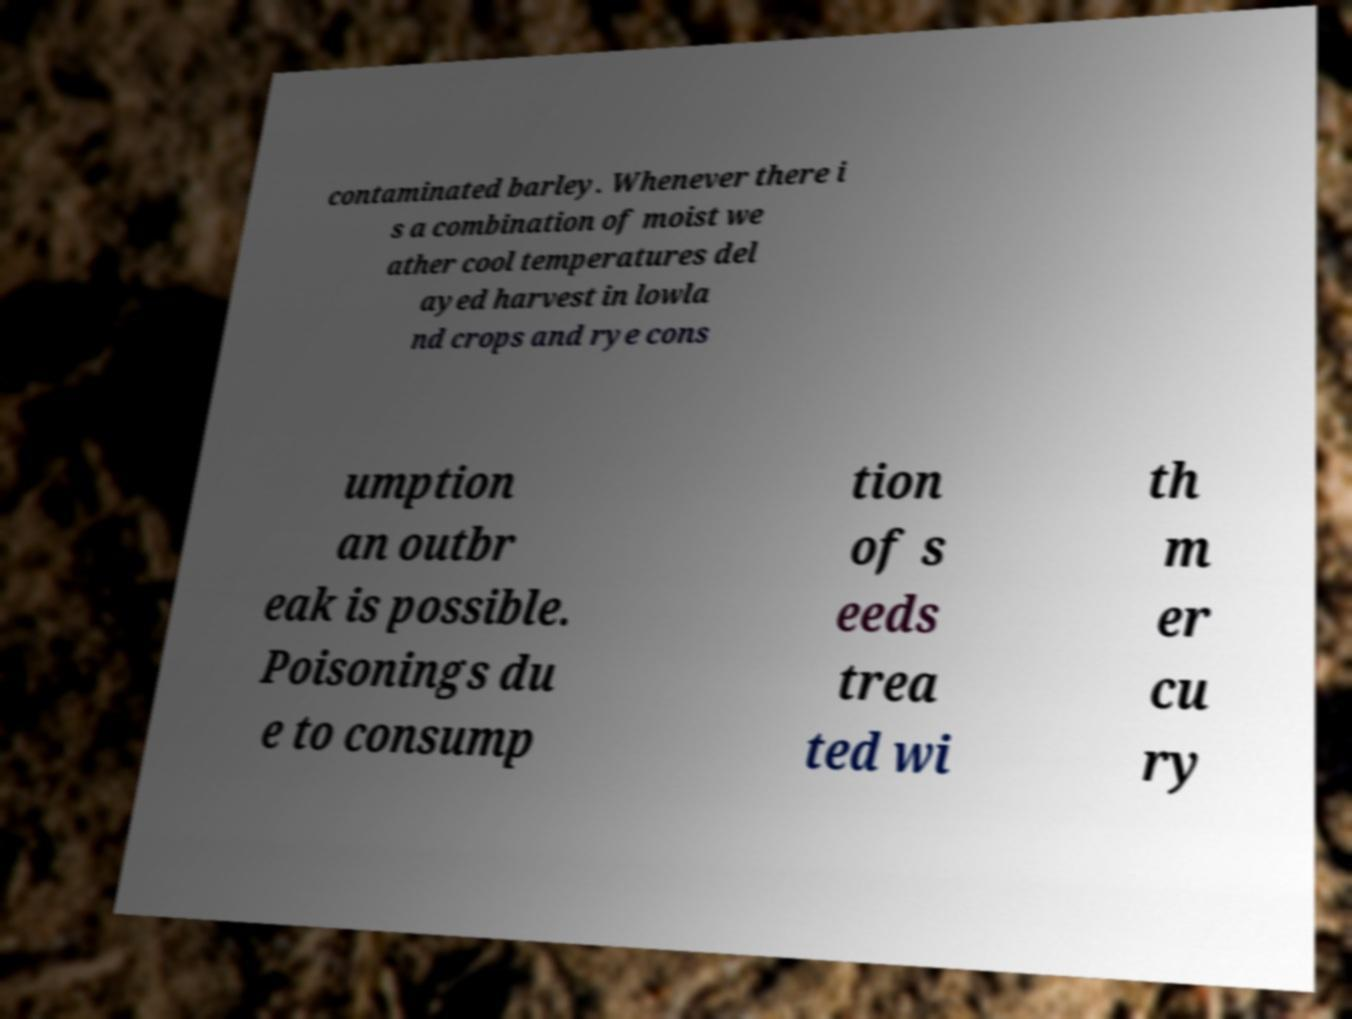What messages or text are displayed in this image? I need them in a readable, typed format. contaminated barley. Whenever there i s a combination of moist we ather cool temperatures del ayed harvest in lowla nd crops and rye cons umption an outbr eak is possible. Poisonings du e to consump tion of s eeds trea ted wi th m er cu ry 